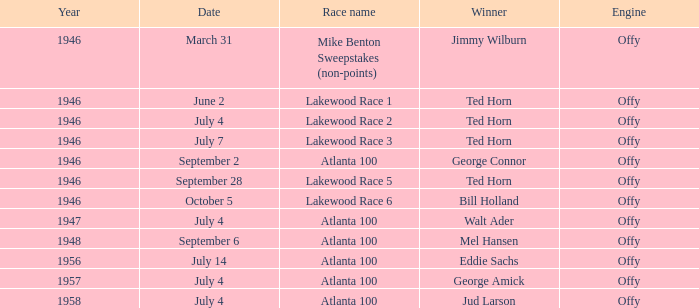Who won on September 6? Mel Hansen. 